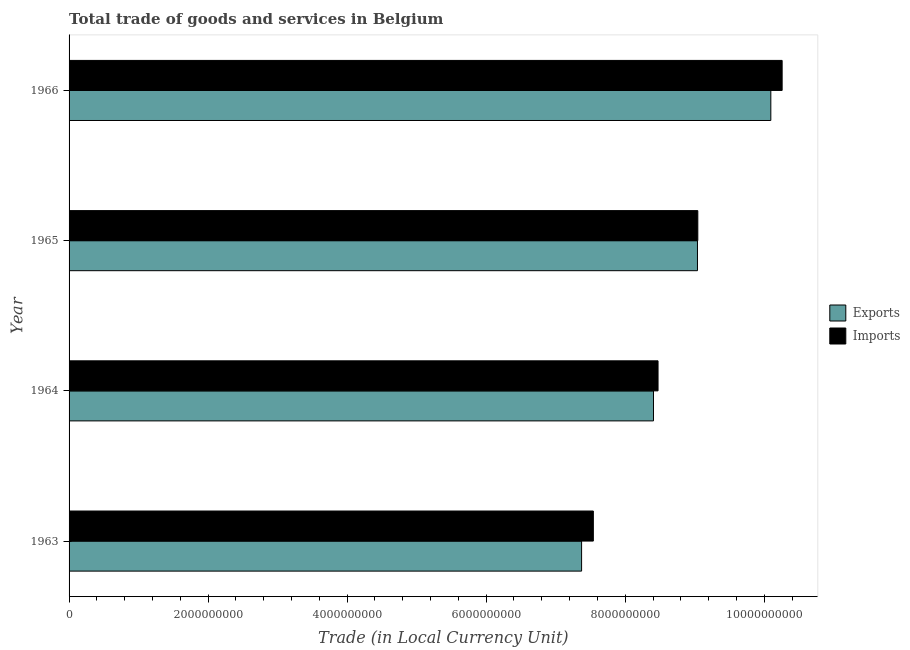How many different coloured bars are there?
Provide a short and direct response. 2. Are the number of bars per tick equal to the number of legend labels?
Provide a short and direct response. Yes. How many bars are there on the 4th tick from the bottom?
Offer a terse response. 2. What is the label of the 2nd group of bars from the top?
Provide a short and direct response. 1965. In how many cases, is the number of bars for a given year not equal to the number of legend labels?
Make the answer very short. 0. What is the imports of goods and services in 1963?
Make the answer very short. 7.54e+09. Across all years, what is the maximum imports of goods and services?
Provide a succinct answer. 1.03e+1. Across all years, what is the minimum imports of goods and services?
Your response must be concise. 7.54e+09. In which year was the imports of goods and services maximum?
Your response must be concise. 1966. In which year was the imports of goods and services minimum?
Provide a short and direct response. 1963. What is the total imports of goods and services in the graph?
Your response must be concise. 3.53e+1. What is the difference between the imports of goods and services in 1964 and that in 1965?
Give a very brief answer. -5.72e+08. What is the difference between the imports of goods and services in 1965 and the export of goods and services in 1966?
Give a very brief answer. -1.05e+09. What is the average export of goods and services per year?
Your answer should be very brief. 8.73e+09. In the year 1966, what is the difference between the imports of goods and services and export of goods and services?
Make the answer very short. 1.63e+08. What is the ratio of the imports of goods and services in 1963 to that in 1965?
Your response must be concise. 0.83. What is the difference between the highest and the second highest imports of goods and services?
Provide a short and direct response. 1.21e+09. What is the difference between the highest and the lowest imports of goods and services?
Your answer should be compact. 2.72e+09. What does the 2nd bar from the top in 1963 represents?
Provide a succinct answer. Exports. What does the 1st bar from the bottom in 1965 represents?
Provide a succinct answer. Exports. How many bars are there?
Provide a succinct answer. 8. Are all the bars in the graph horizontal?
Offer a terse response. Yes. How many years are there in the graph?
Your answer should be very brief. 4. What is the difference between two consecutive major ticks on the X-axis?
Provide a short and direct response. 2.00e+09. How are the legend labels stacked?
Your answer should be very brief. Vertical. What is the title of the graph?
Provide a short and direct response. Total trade of goods and services in Belgium. Does "Secondary education" appear as one of the legend labels in the graph?
Your response must be concise. No. What is the label or title of the X-axis?
Make the answer very short. Trade (in Local Currency Unit). What is the Trade (in Local Currency Unit) in Exports in 1963?
Your response must be concise. 7.37e+09. What is the Trade (in Local Currency Unit) of Imports in 1963?
Ensure brevity in your answer.  7.54e+09. What is the Trade (in Local Currency Unit) of Exports in 1964?
Your answer should be very brief. 8.41e+09. What is the Trade (in Local Currency Unit) of Imports in 1964?
Keep it short and to the point. 8.47e+09. What is the Trade (in Local Currency Unit) in Exports in 1965?
Your answer should be compact. 9.04e+09. What is the Trade (in Local Currency Unit) of Imports in 1965?
Your answer should be very brief. 9.04e+09. What is the Trade (in Local Currency Unit) of Exports in 1966?
Ensure brevity in your answer.  1.01e+1. What is the Trade (in Local Currency Unit) of Imports in 1966?
Keep it short and to the point. 1.03e+1. Across all years, what is the maximum Trade (in Local Currency Unit) in Exports?
Ensure brevity in your answer.  1.01e+1. Across all years, what is the maximum Trade (in Local Currency Unit) in Imports?
Offer a terse response. 1.03e+1. Across all years, what is the minimum Trade (in Local Currency Unit) of Exports?
Give a very brief answer. 7.37e+09. Across all years, what is the minimum Trade (in Local Currency Unit) in Imports?
Ensure brevity in your answer.  7.54e+09. What is the total Trade (in Local Currency Unit) in Exports in the graph?
Keep it short and to the point. 3.49e+1. What is the total Trade (in Local Currency Unit) in Imports in the graph?
Your answer should be compact. 3.53e+1. What is the difference between the Trade (in Local Currency Unit) in Exports in 1963 and that in 1964?
Give a very brief answer. -1.03e+09. What is the difference between the Trade (in Local Currency Unit) in Imports in 1963 and that in 1964?
Provide a short and direct response. -9.31e+08. What is the difference between the Trade (in Local Currency Unit) in Exports in 1963 and that in 1965?
Offer a very short reply. -1.67e+09. What is the difference between the Trade (in Local Currency Unit) in Imports in 1963 and that in 1965?
Make the answer very short. -1.50e+09. What is the difference between the Trade (in Local Currency Unit) in Exports in 1963 and that in 1966?
Make the answer very short. -2.72e+09. What is the difference between the Trade (in Local Currency Unit) of Imports in 1963 and that in 1966?
Provide a succinct answer. -2.72e+09. What is the difference between the Trade (in Local Currency Unit) of Exports in 1964 and that in 1965?
Ensure brevity in your answer.  -6.33e+08. What is the difference between the Trade (in Local Currency Unit) in Imports in 1964 and that in 1965?
Provide a short and direct response. -5.72e+08. What is the difference between the Trade (in Local Currency Unit) of Exports in 1964 and that in 1966?
Your answer should be compact. -1.69e+09. What is the difference between the Trade (in Local Currency Unit) of Imports in 1964 and that in 1966?
Your response must be concise. -1.79e+09. What is the difference between the Trade (in Local Currency Unit) of Exports in 1965 and that in 1966?
Offer a terse response. -1.06e+09. What is the difference between the Trade (in Local Currency Unit) in Imports in 1965 and that in 1966?
Offer a very short reply. -1.21e+09. What is the difference between the Trade (in Local Currency Unit) in Exports in 1963 and the Trade (in Local Currency Unit) in Imports in 1964?
Provide a succinct answer. -1.10e+09. What is the difference between the Trade (in Local Currency Unit) of Exports in 1963 and the Trade (in Local Currency Unit) of Imports in 1965?
Offer a terse response. -1.67e+09. What is the difference between the Trade (in Local Currency Unit) in Exports in 1963 and the Trade (in Local Currency Unit) in Imports in 1966?
Offer a very short reply. -2.88e+09. What is the difference between the Trade (in Local Currency Unit) in Exports in 1964 and the Trade (in Local Currency Unit) in Imports in 1965?
Keep it short and to the point. -6.38e+08. What is the difference between the Trade (in Local Currency Unit) of Exports in 1964 and the Trade (in Local Currency Unit) of Imports in 1966?
Your response must be concise. -1.85e+09. What is the difference between the Trade (in Local Currency Unit) of Exports in 1965 and the Trade (in Local Currency Unit) of Imports in 1966?
Offer a very short reply. -1.22e+09. What is the average Trade (in Local Currency Unit) of Exports per year?
Your response must be concise. 8.73e+09. What is the average Trade (in Local Currency Unit) of Imports per year?
Your response must be concise. 8.83e+09. In the year 1963, what is the difference between the Trade (in Local Currency Unit) of Exports and Trade (in Local Currency Unit) of Imports?
Offer a very short reply. -1.69e+08. In the year 1964, what is the difference between the Trade (in Local Currency Unit) in Exports and Trade (in Local Currency Unit) in Imports?
Your answer should be compact. -6.56e+07. In the year 1965, what is the difference between the Trade (in Local Currency Unit) in Exports and Trade (in Local Currency Unit) in Imports?
Provide a short and direct response. -5.07e+06. In the year 1966, what is the difference between the Trade (in Local Currency Unit) of Exports and Trade (in Local Currency Unit) of Imports?
Give a very brief answer. -1.63e+08. What is the ratio of the Trade (in Local Currency Unit) of Exports in 1963 to that in 1964?
Ensure brevity in your answer.  0.88. What is the ratio of the Trade (in Local Currency Unit) of Imports in 1963 to that in 1964?
Give a very brief answer. 0.89. What is the ratio of the Trade (in Local Currency Unit) of Exports in 1963 to that in 1965?
Offer a very short reply. 0.82. What is the ratio of the Trade (in Local Currency Unit) in Imports in 1963 to that in 1965?
Give a very brief answer. 0.83. What is the ratio of the Trade (in Local Currency Unit) of Exports in 1963 to that in 1966?
Your answer should be compact. 0.73. What is the ratio of the Trade (in Local Currency Unit) of Imports in 1963 to that in 1966?
Provide a short and direct response. 0.74. What is the ratio of the Trade (in Local Currency Unit) of Imports in 1964 to that in 1965?
Provide a short and direct response. 0.94. What is the ratio of the Trade (in Local Currency Unit) in Exports in 1964 to that in 1966?
Your answer should be compact. 0.83. What is the ratio of the Trade (in Local Currency Unit) of Imports in 1964 to that in 1966?
Make the answer very short. 0.83. What is the ratio of the Trade (in Local Currency Unit) of Exports in 1965 to that in 1966?
Offer a terse response. 0.9. What is the ratio of the Trade (in Local Currency Unit) of Imports in 1965 to that in 1966?
Give a very brief answer. 0.88. What is the difference between the highest and the second highest Trade (in Local Currency Unit) in Exports?
Give a very brief answer. 1.06e+09. What is the difference between the highest and the second highest Trade (in Local Currency Unit) in Imports?
Offer a terse response. 1.21e+09. What is the difference between the highest and the lowest Trade (in Local Currency Unit) in Exports?
Keep it short and to the point. 2.72e+09. What is the difference between the highest and the lowest Trade (in Local Currency Unit) in Imports?
Provide a short and direct response. 2.72e+09. 